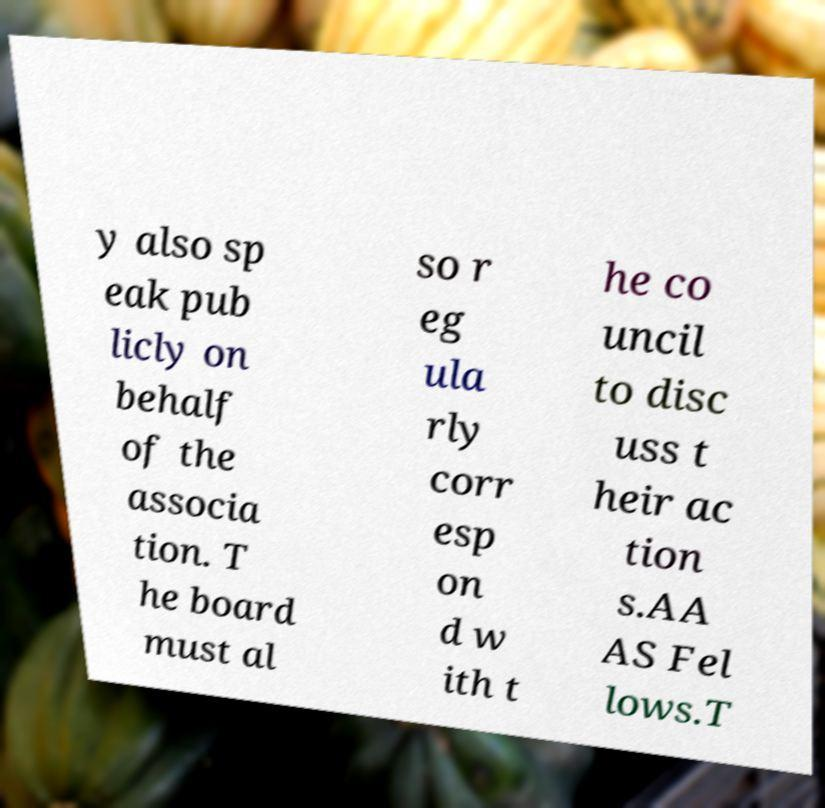Could you assist in decoding the text presented in this image and type it out clearly? y also sp eak pub licly on behalf of the associa tion. T he board must al so r eg ula rly corr esp on d w ith t he co uncil to disc uss t heir ac tion s.AA AS Fel lows.T 